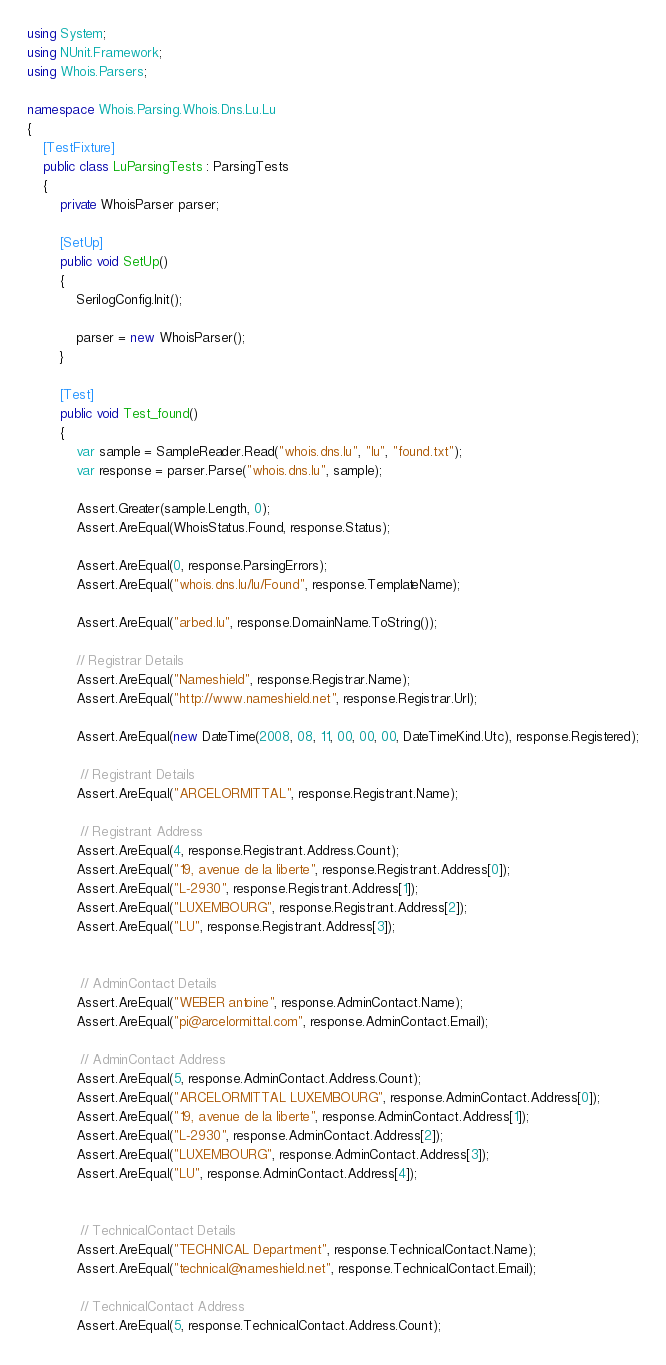<code> <loc_0><loc_0><loc_500><loc_500><_C#_>using System;
using NUnit.Framework;
using Whois.Parsers;

namespace Whois.Parsing.Whois.Dns.Lu.Lu
{
    [TestFixture]
    public class LuParsingTests : ParsingTests
    {
        private WhoisParser parser;

        [SetUp]
        public void SetUp()
        {
            SerilogConfig.Init();

            parser = new WhoisParser();
        }

        [Test]
        public void Test_found()
        {
            var sample = SampleReader.Read("whois.dns.lu", "lu", "found.txt");
            var response = parser.Parse("whois.dns.lu", sample);

            Assert.Greater(sample.Length, 0);
            Assert.AreEqual(WhoisStatus.Found, response.Status);

            Assert.AreEqual(0, response.ParsingErrors);
            Assert.AreEqual("whois.dns.lu/lu/Found", response.TemplateName);

            Assert.AreEqual("arbed.lu", response.DomainName.ToString());

            // Registrar Details
            Assert.AreEqual("Nameshield", response.Registrar.Name);
            Assert.AreEqual("http://www.nameshield.net", response.Registrar.Url);

            Assert.AreEqual(new DateTime(2008, 08, 11, 00, 00, 00, DateTimeKind.Utc), response.Registered);

             // Registrant Details
            Assert.AreEqual("ARCELORMITTAL", response.Registrant.Name);

             // Registrant Address
            Assert.AreEqual(4, response.Registrant.Address.Count);
            Assert.AreEqual("19, avenue de la liberte", response.Registrant.Address[0]);
            Assert.AreEqual("L-2930", response.Registrant.Address[1]);
            Assert.AreEqual("LUXEMBOURG", response.Registrant.Address[2]);
            Assert.AreEqual("LU", response.Registrant.Address[3]);


             // AdminContact Details
            Assert.AreEqual("WEBER antoine", response.AdminContact.Name);
            Assert.AreEqual("pi@arcelormittal.com", response.AdminContact.Email);

             // AdminContact Address
            Assert.AreEqual(5, response.AdminContact.Address.Count);
            Assert.AreEqual("ARCELORMITTAL LUXEMBOURG", response.AdminContact.Address[0]);
            Assert.AreEqual("19, avenue de la liberte", response.AdminContact.Address[1]);
            Assert.AreEqual("L-2930", response.AdminContact.Address[2]);
            Assert.AreEqual("LUXEMBOURG", response.AdminContact.Address[3]);
            Assert.AreEqual("LU", response.AdminContact.Address[4]);


             // TechnicalContact Details
            Assert.AreEqual("TECHNICAL Department", response.TechnicalContact.Name);
            Assert.AreEqual("technical@nameshield.net", response.TechnicalContact.Email);

             // TechnicalContact Address
            Assert.AreEqual(5, response.TechnicalContact.Address.Count);</code> 